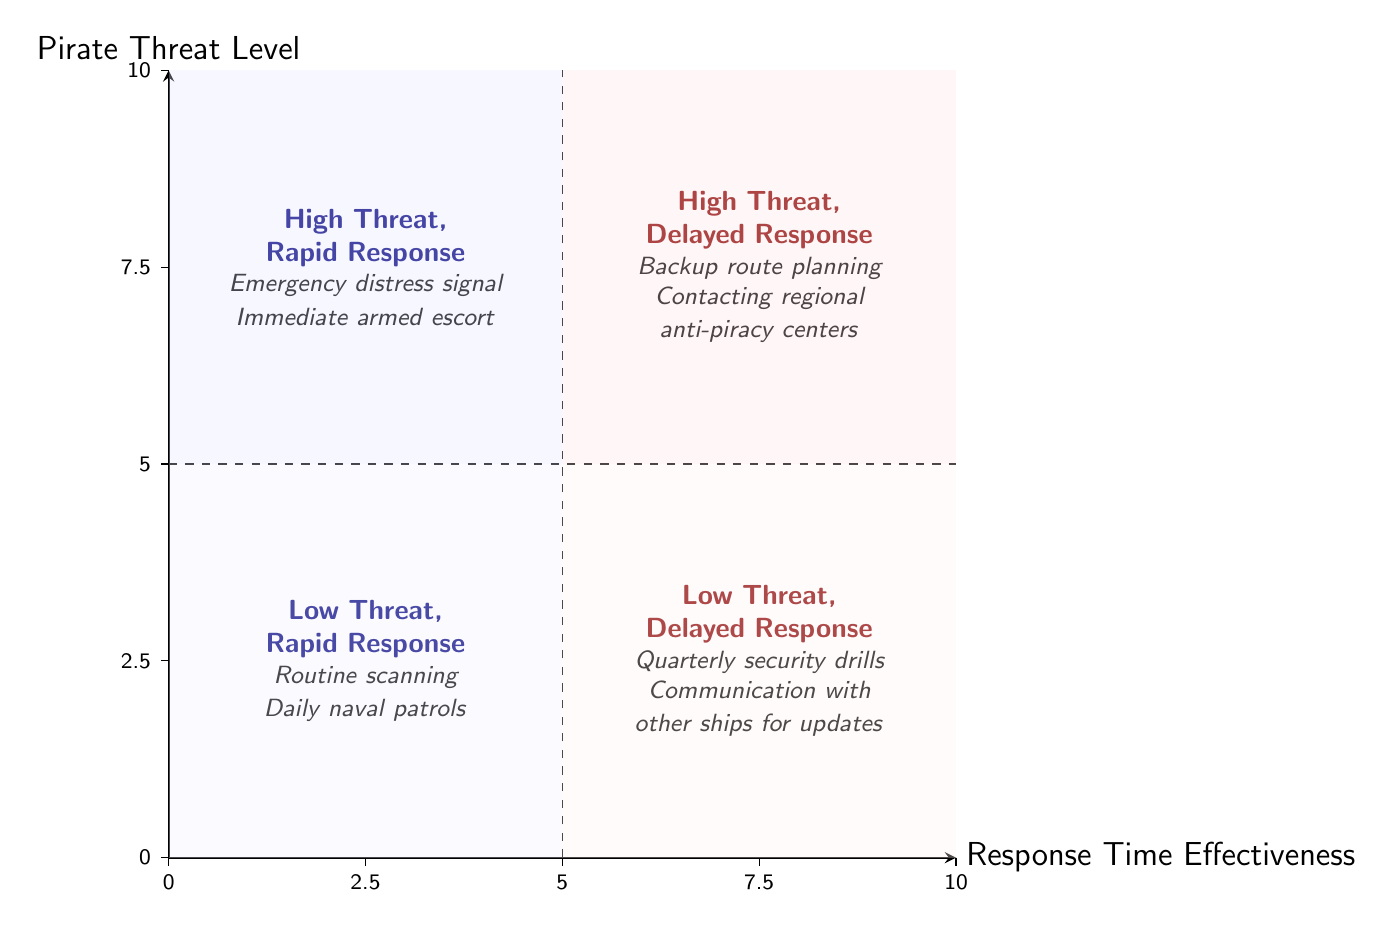What are the examples listed in the "High Threat, Rapid Response" quadrant? The quadrant labeled "High Threat, Rapid Response" includes examples such as "Emergency distress signal" and "Immediate armed escort." These can be found directly within the text associated with the quadrant in the diagram.
Answer: Emergency distress signal, Immediate armed escort Which quadrant represents high threat with delayed response? The quadrant representing high threat with delayed response is the one located in the upper right area of the diagram, labeled "High Threat, Delayed Response." It contains specific examples detailing this security measure.
Answer: High Threat, Delayed Response How many quadrants are there in the diagram? The diagram contains a total of four quadrants, each representing different combinations of pirate threat levels and response times. This can be determined by observing the divisions in the diagram.
Answer: Four What type of activities are suggested for the "Low Threat, Delayed Response" quadrant? The activities suggested for the "Low Threat, Delayed Response" quadrant include "Quarterly security drills" and "Communication with other ships for updates," as seen in the text specific to that quadrant in the diagram.
Answer: Quarterly security drills, Communication with other ships for updates Which quadrant has the least effective response time for high threat levels? The quadrant with the least effective response time for high threat levels is "High Threat, Delayed Response," located in the upper right quadrant of the diagram. It specifically outlines that response times are not rapid in this situation.
Answer: High Threat, Delayed Response What are the coordinates of the "Low Threat, Rapid Response" quadrant? The "Low Threat, Rapid Response" quadrant is located at coordinates (2.5, 2.5) in the diagram, corresponding to its placement on the grid outlined by the X and Y axes. This placement indicates that both threat level and response effectiveness are low in this scenario.
Answer: 2.5, 2.5 Which quadrant contains the example of "Daily naval patrols"? The example "Daily naval patrols" is found in the "Low Threat, Rapid Response" quadrant located in the bottom left section of the diagram. This quadrant details proactive measures for low threat levels with efficient responses.
Answer: Low Threat, Rapid Response What is the general trend shown between threat levels and response effectiveness? The general trend illustrated in the quadrant chart is that as pirate threat levels increase, the effectiveness of the response time can vary widely, showing a potential need for adaptability in response strategies. This reflects a direct correlation between threat and the necessity for rapid response measures.
Answer: Increasing threat, varying response effectiveness 